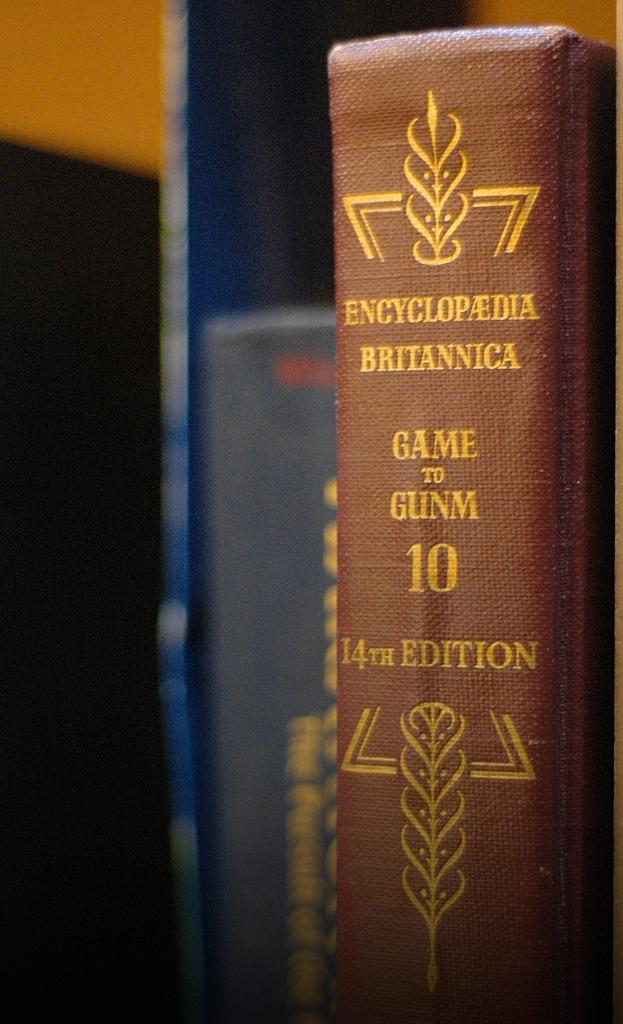<image>
Give a short and clear explanation of the subsequent image. The Encyclopedia Britannica 14th Edition is seen in close up. 